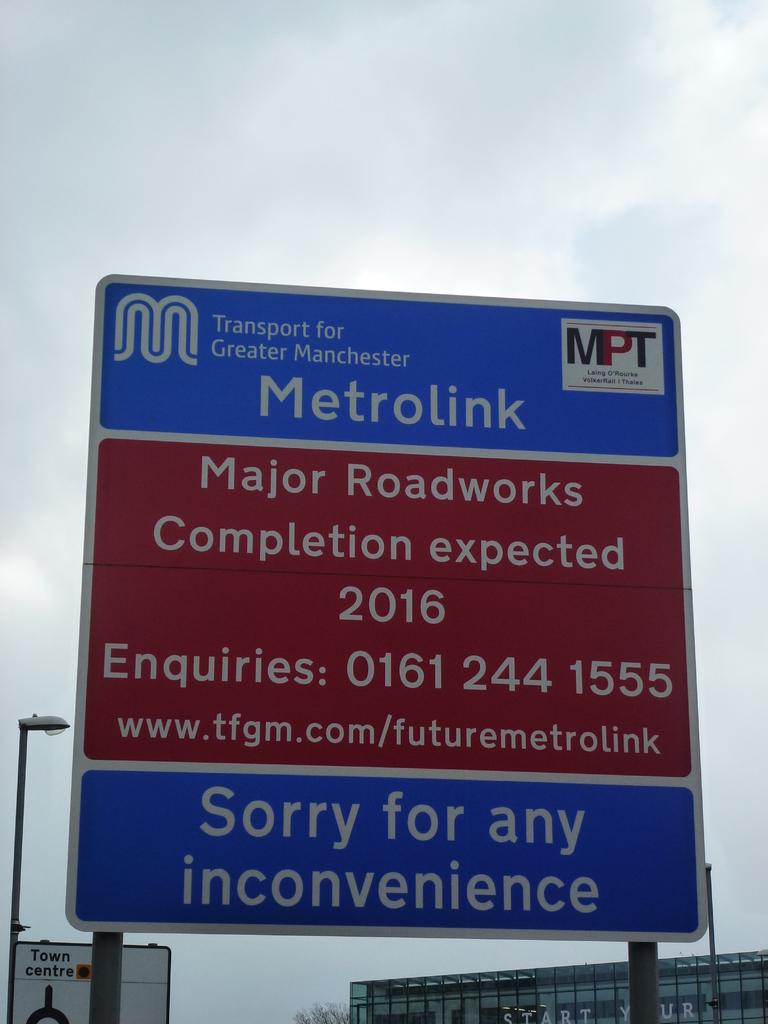<image>
Write a terse but informative summary of the picture. A blue and red sign explaining the Metrolink project on a sunny day. 